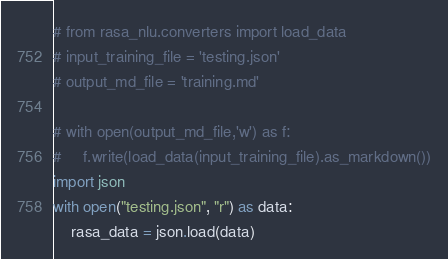<code> <loc_0><loc_0><loc_500><loc_500><_Python_># from rasa_nlu.converters import load_data
# input_training_file = 'testing.json'
# output_md_file = 'training.md'

# with open(output_md_file,'w') as f:
#     f.write(load_data(input_training_file).as_markdown())
import json
with open("testing.json", "r") as data:
    rasa_data = json.load(data)


</code> 